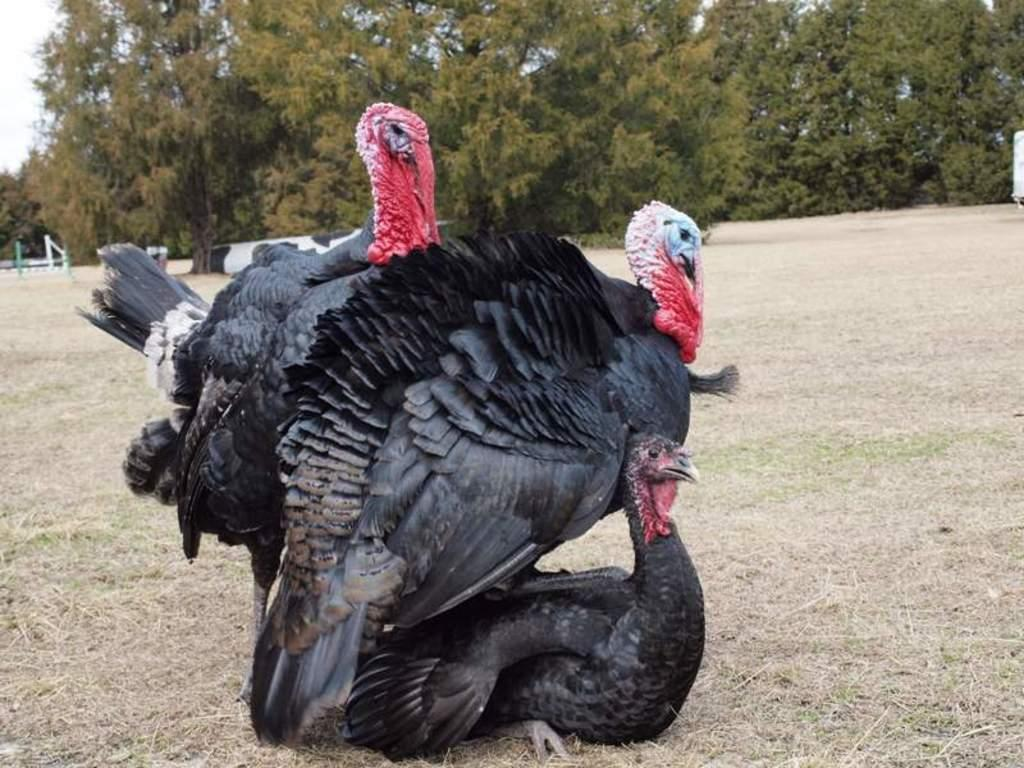What type of animals can be seen in the image? There are birds in the image. What is visible beneath the birds in the image? The ground is visible in the image. What type of vegetation can be seen in the image? There are trees in the image. What else can be seen in the image besides the birds and trees? There are objects in the image. What is visible above the birds and objects in the image? The sky is visible in the image. What is the name of the dog in the image? There is no dog present in the image; it features birds, trees, and objects. 